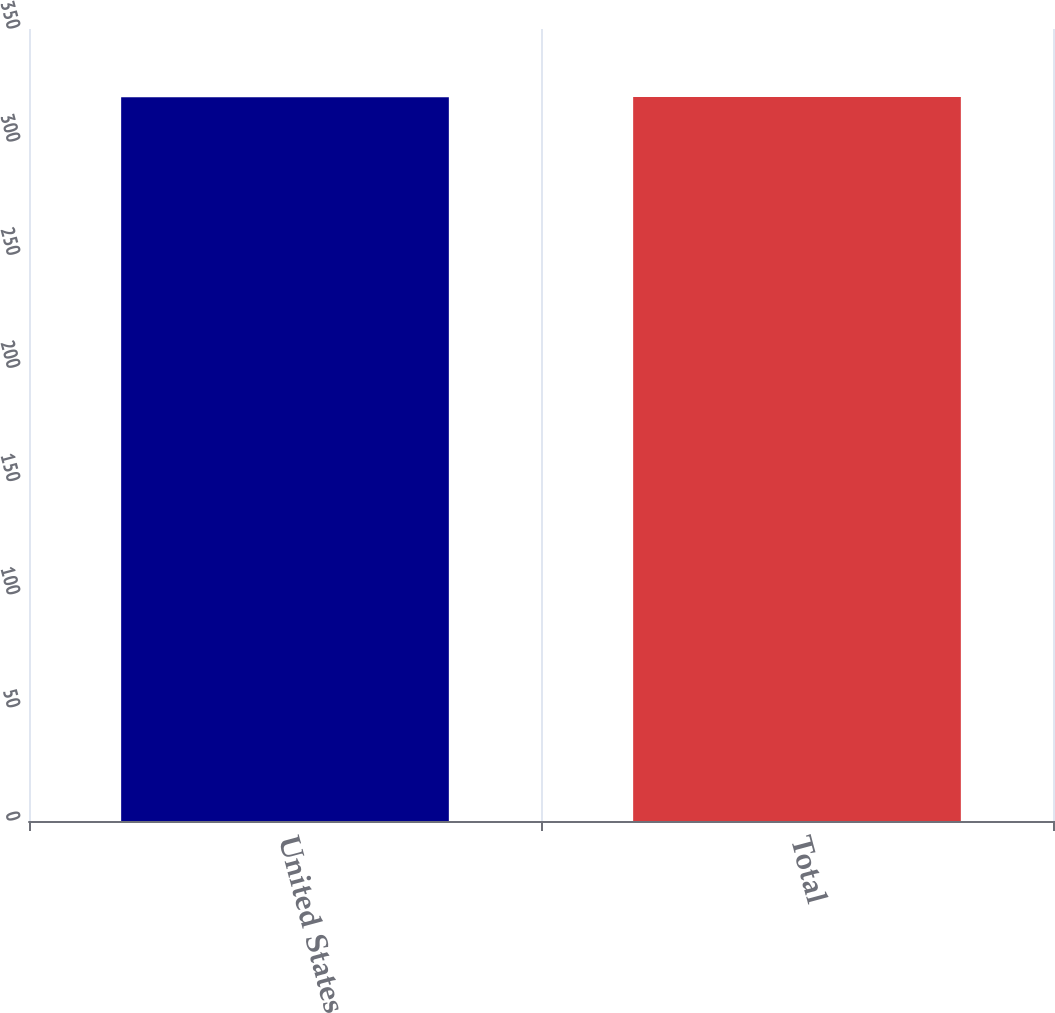Convert chart. <chart><loc_0><loc_0><loc_500><loc_500><bar_chart><fcel>United States<fcel>Total<nl><fcel>319.8<fcel>319.9<nl></chart> 